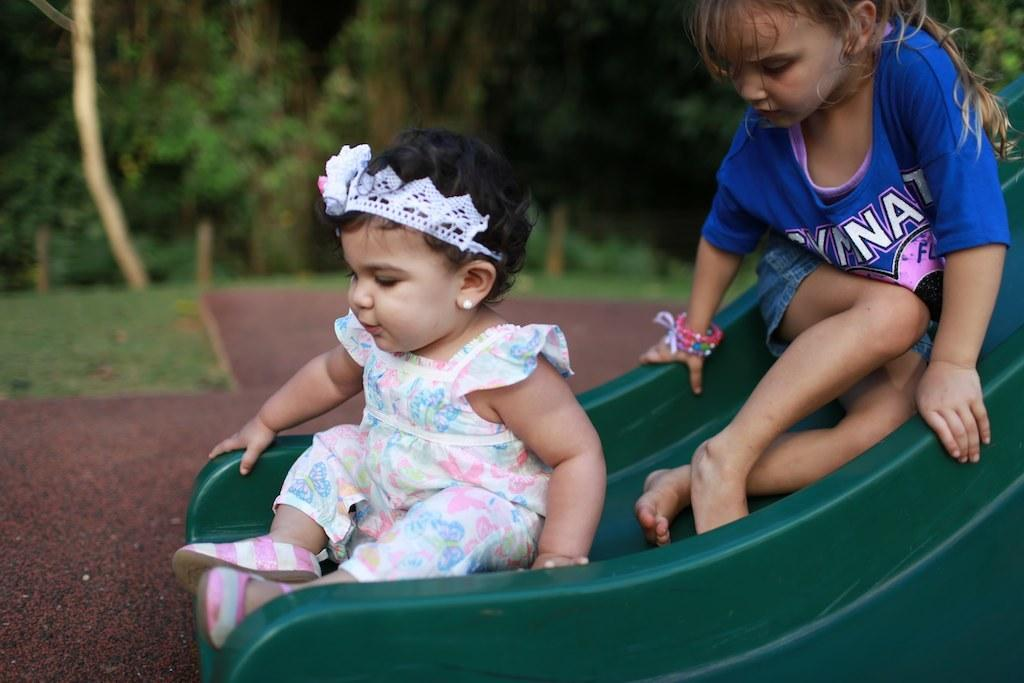How many kids are in the image? There are two kids in the image. What are the kids doing in the image? The kids are sliding on a sliding board. What can be seen in the background of the image? There are trees and grass in the background of the image. What type of government is depicted in the image? There is no depiction of a government in the image; it features two kids sliding on a sliding board with trees and grass in the background. 